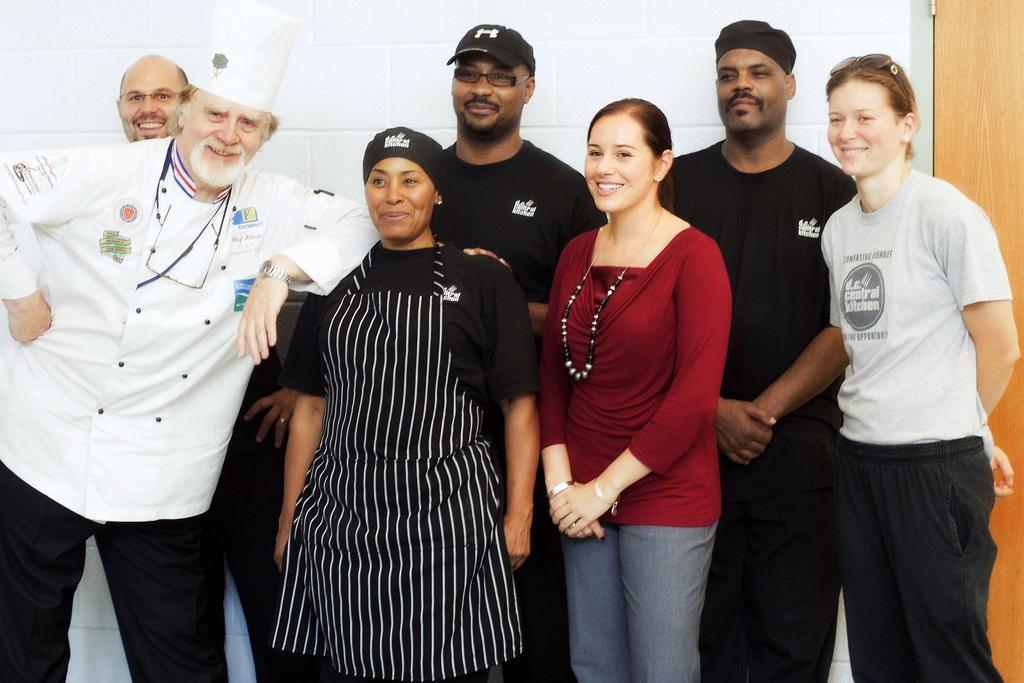Describe this image in one or two sentences. In this image I can see group of people standing. The person in front wearing black dress and the person at left wearing white shirt, black pant. At the back I can see wall in white color and door in brown color. 